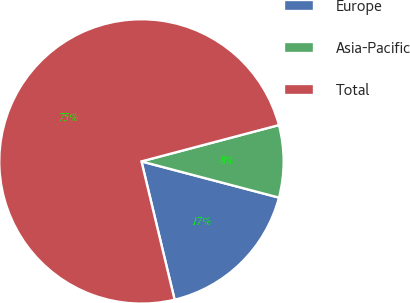Convert chart to OTSL. <chart><loc_0><loc_0><loc_500><loc_500><pie_chart><fcel>Europe<fcel>Asia-Pacific<fcel>Total<nl><fcel>17.16%<fcel>8.21%<fcel>74.63%<nl></chart> 